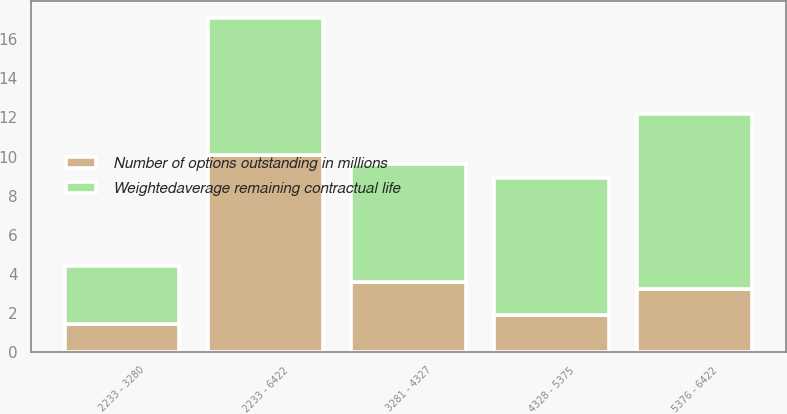Convert chart. <chart><loc_0><loc_0><loc_500><loc_500><stacked_bar_chart><ecel><fcel>2233 - 3280<fcel>3281 - 4327<fcel>4328 - 5375<fcel>5376 - 6422<fcel>2233 - 6422<nl><fcel>Number of options outstanding in millions<fcel>1.4<fcel>3.6<fcel>1.9<fcel>3.2<fcel>10.1<nl><fcel>Weightedaverage remaining contractual life<fcel>3<fcel>6<fcel>7<fcel>9<fcel>7<nl></chart> 